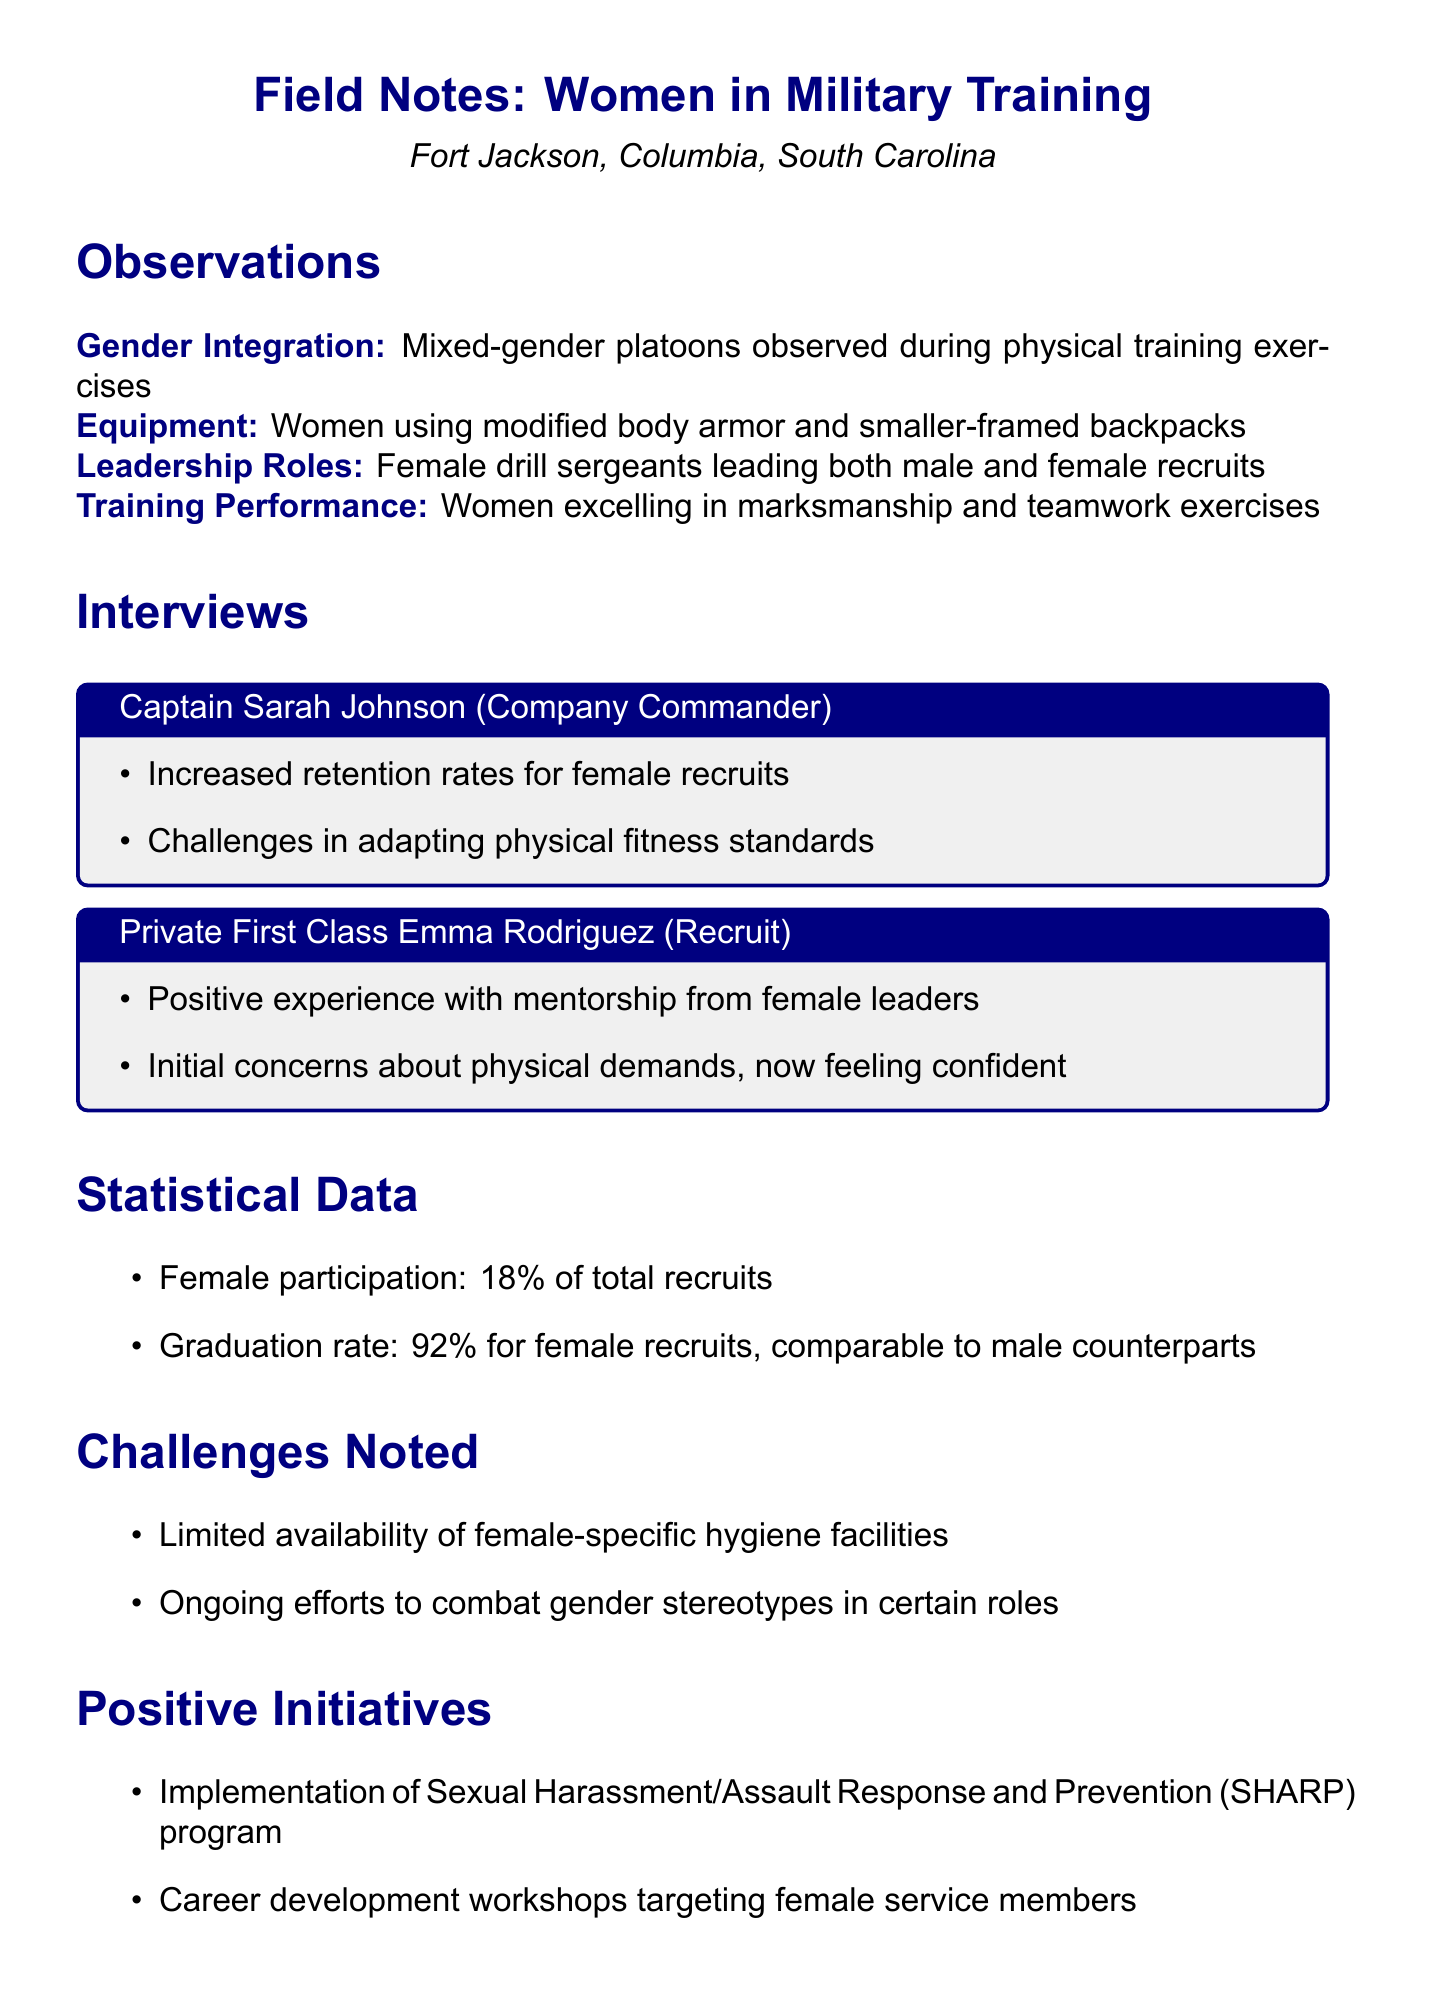What is the name of the military training facility? The document states that the facility is called Fort Jackson, located in Columbia, South Carolina.
Answer: Fort Jackson What percentage of total recruits are female? The document provides a statistic indicating that female participation is 18% of total recruits.
Answer: 18% Who is the Company Commander interviewed? The document mentions Captain Sarah Johnson as the Company Commander interviewed.
Answer: Captain Sarah Johnson What is the graduation rate for female recruits? According to the document, the graduation rate for female recruits is 92%, which is noted as comparable to male counterparts.
Answer: 92% What challenge related to facilities is noted in the observations? The document highlights limited availability of female-specific hygiene facilities as a challenge.
Answer: Limited availability of female-specific hygiene facilities What positive initiative is implemented for female service members? The document states that there are career development workshops targeting female service members as a positive initiative.
Answer: Career development workshops How are female drill sergeants described in their roles? The observations in the document note that female drill sergeants are leading both male and female recruits.
Answer: Leading both male and female recruits What physical fitness adaptation challenge is mentioned? Captain Sarah Johnson mentioned challenges in adapting physical fitness standards in the interview.
Answer: Challenges in adapting physical fitness standards What type of training exercises did women excel in? The observations reveal that women excelled in marksmanship and teamwork exercises during training.
Answer: Marksmanship and teamwork exercises 